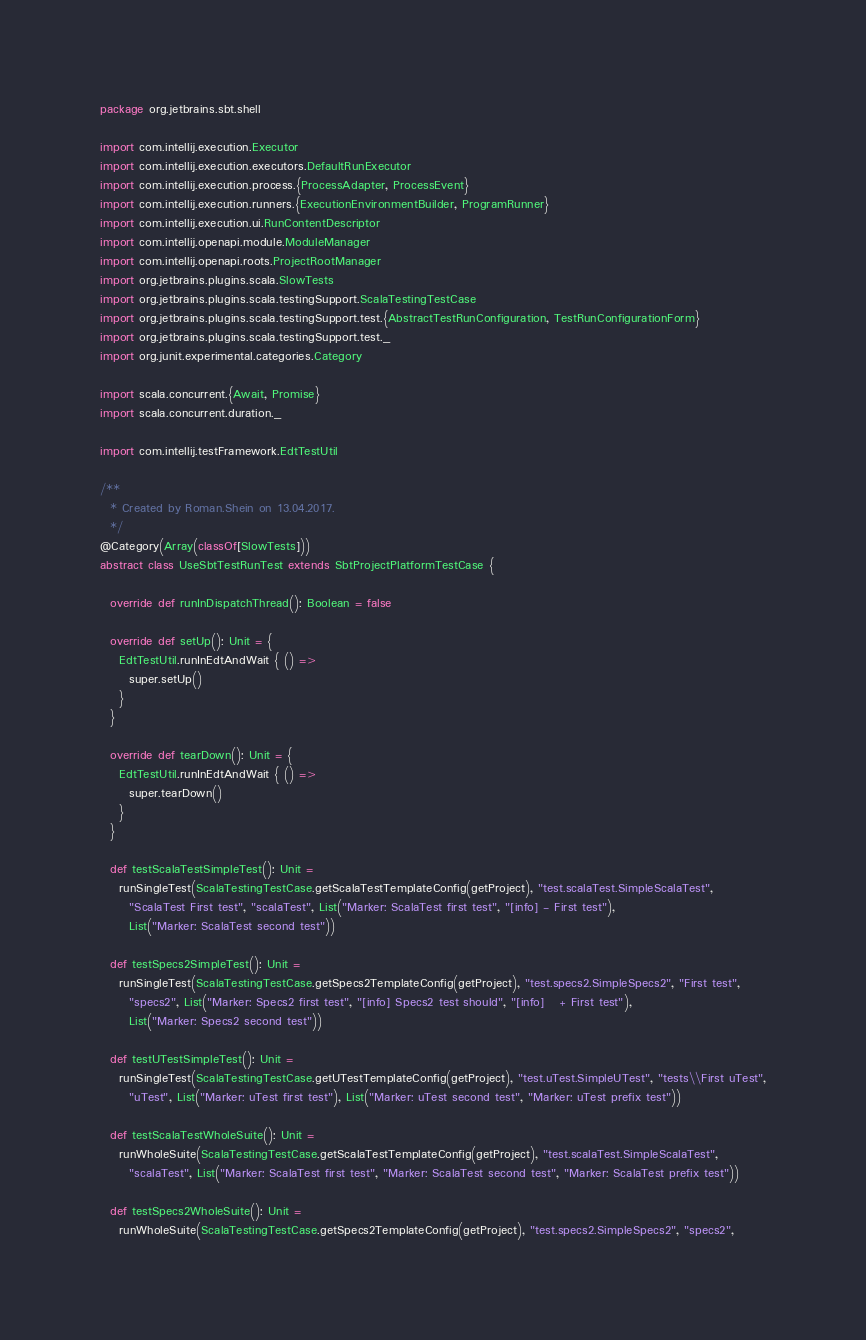Convert code to text. <code><loc_0><loc_0><loc_500><loc_500><_Scala_>package org.jetbrains.sbt.shell

import com.intellij.execution.Executor
import com.intellij.execution.executors.DefaultRunExecutor
import com.intellij.execution.process.{ProcessAdapter, ProcessEvent}
import com.intellij.execution.runners.{ExecutionEnvironmentBuilder, ProgramRunner}
import com.intellij.execution.ui.RunContentDescriptor
import com.intellij.openapi.module.ModuleManager
import com.intellij.openapi.roots.ProjectRootManager
import org.jetbrains.plugins.scala.SlowTests
import org.jetbrains.plugins.scala.testingSupport.ScalaTestingTestCase
import org.jetbrains.plugins.scala.testingSupport.test.{AbstractTestRunConfiguration, TestRunConfigurationForm}
import org.jetbrains.plugins.scala.testingSupport.test._
import org.junit.experimental.categories.Category

import scala.concurrent.{Await, Promise}
import scala.concurrent.duration._

import com.intellij.testFramework.EdtTestUtil

/**
  * Created by Roman.Shein on 13.04.2017.
  */
@Category(Array(classOf[SlowTests]))
abstract class UseSbtTestRunTest extends SbtProjectPlatformTestCase {

  override def runInDispatchThread(): Boolean = false

  override def setUp(): Unit = {
    EdtTestUtil.runInEdtAndWait { () =>
      super.setUp()
    }
  }

  override def tearDown(): Unit = {
    EdtTestUtil.runInEdtAndWait { () =>
      super.tearDown()
    }
  }

  def testScalaTestSimpleTest(): Unit =
    runSingleTest(ScalaTestingTestCase.getScalaTestTemplateConfig(getProject), "test.scalaTest.SimpleScalaTest",
      "ScalaTest First test", "scalaTest", List("Marker: ScalaTest first test", "[info] - First test"),
      List("Marker: ScalaTest second test"))

  def testSpecs2SimpleTest(): Unit =
    runSingleTest(ScalaTestingTestCase.getSpecs2TemplateConfig(getProject), "test.specs2.SimpleSpecs2", "First test",
      "specs2", List("Marker: Specs2 first test", "[info] Specs2 test should", "[info]   + First test"),
      List("Marker: Specs2 second test"))

  def testUTestSimpleTest(): Unit =
    runSingleTest(ScalaTestingTestCase.getUTestTemplateConfig(getProject), "test.uTest.SimpleUTest", "tests\\First uTest",
      "uTest", List("Marker: uTest first test"), List("Marker: uTest second test", "Marker: uTest prefix test"))

  def testScalaTestWholeSuite(): Unit =
    runWholeSuite(ScalaTestingTestCase.getScalaTestTemplateConfig(getProject), "test.scalaTest.SimpleScalaTest",
      "scalaTest", List("Marker: ScalaTest first test", "Marker: ScalaTest second test", "Marker: ScalaTest prefix test"))

  def testSpecs2WholeSuite(): Unit =
    runWholeSuite(ScalaTestingTestCase.getSpecs2TemplateConfig(getProject), "test.specs2.SimpleSpecs2", "specs2",</code> 